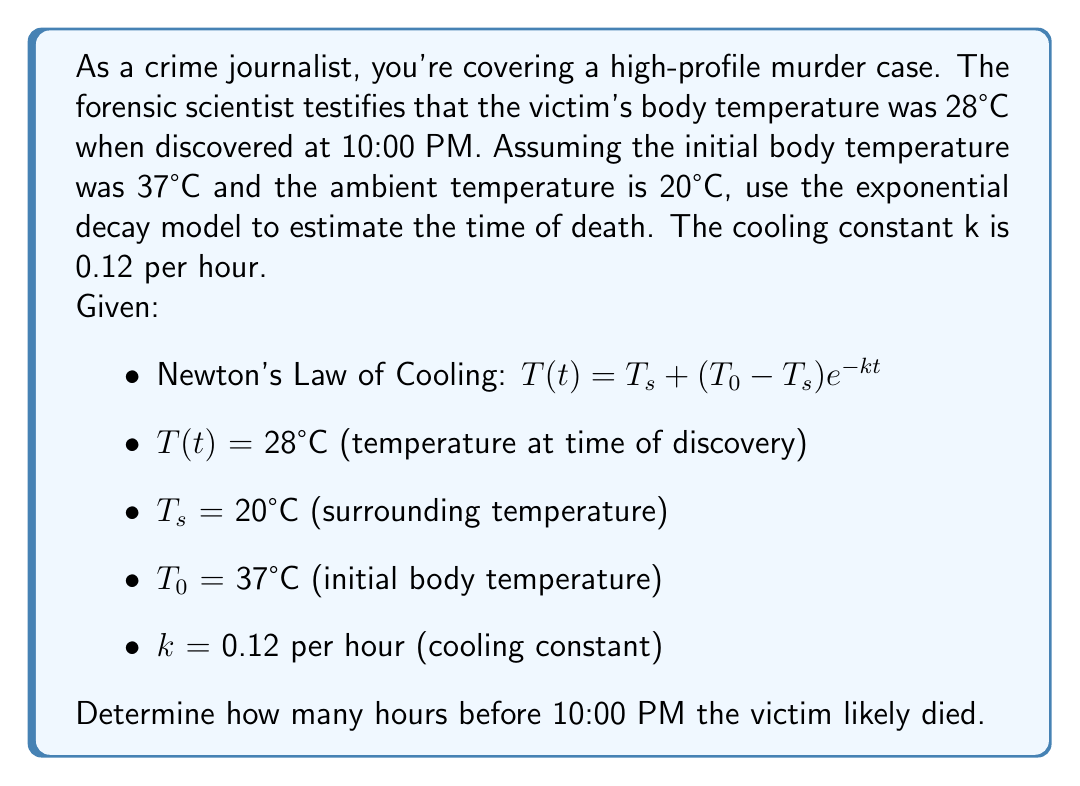Give your solution to this math problem. Let's approach this step-by-step:

1) We'll use Newton's Law of Cooling: $T(t) = T_s + (T_0 - T_s)e^{-kt}$

2) Substitute the known values:
   $28 = 20 + (37 - 20)e^{-0.12t}$

3) Simplify:
   $28 = 20 + 17e^{-0.12t}$

4) Subtract 20 from both sides:
   $8 = 17e^{-0.12t}$

5) Divide both sides by 17:
   $\frac{8}{17} = e^{-0.12t}$

6) Take the natural log of both sides:
   $\ln(\frac{8}{17}) = -0.12t$

7) Solve for t:
   $t = -\frac{\ln(\frac{8}{17})}{0.12}$

8) Calculate:
   $t \approx 5.95$ hours

Therefore, the victim likely died about 5.95 hours before the body was discovered at 10:00 PM.
Answer: 5.95 hours before 10:00 PM 